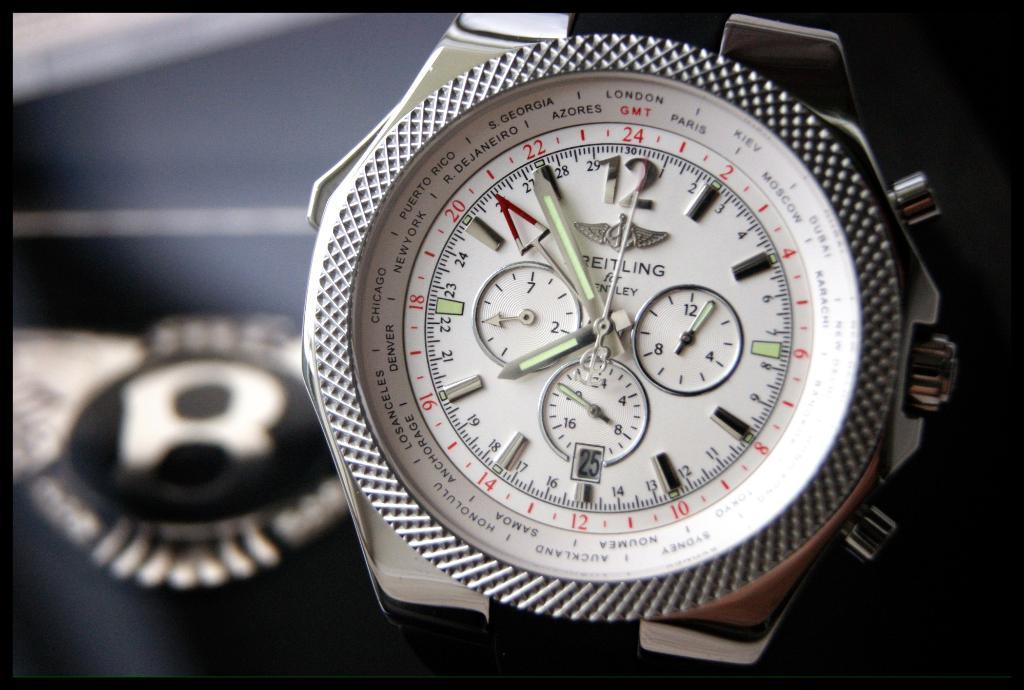<image>
Provide a brief description of the given image. Black and silver watch that is includes the time and London. 